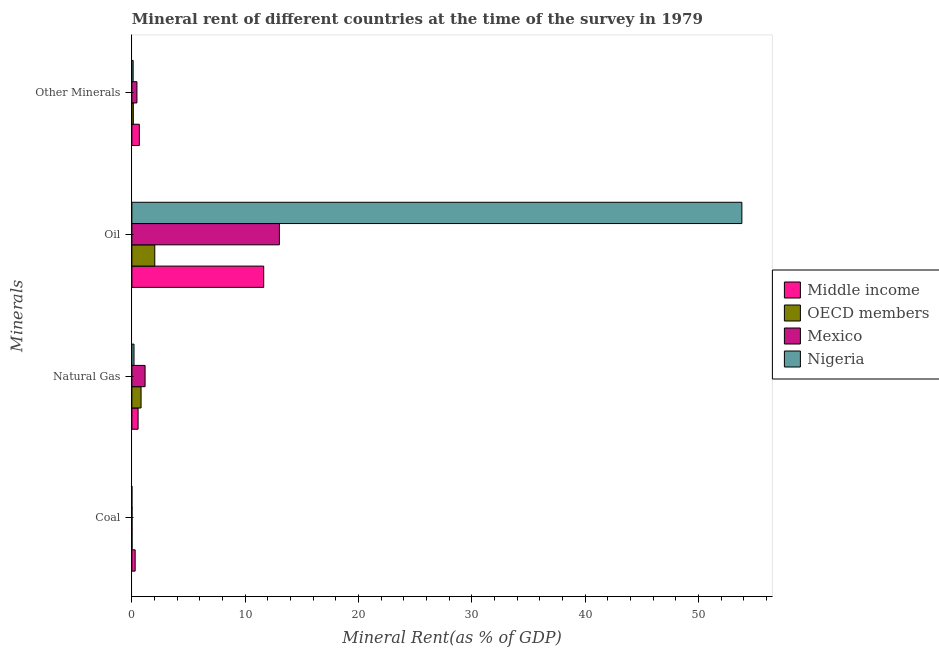How many bars are there on the 3rd tick from the bottom?
Offer a terse response. 4. What is the label of the 3rd group of bars from the top?
Provide a short and direct response. Natural Gas. What is the natural gas rent in OECD members?
Your answer should be very brief. 0.81. Across all countries, what is the maximum natural gas rent?
Ensure brevity in your answer.  1.16. Across all countries, what is the minimum oil rent?
Your answer should be compact. 2.02. What is the total coal rent in the graph?
Provide a short and direct response. 0.32. What is the difference between the oil rent in Nigeria and that in OECD members?
Offer a very short reply. 51.81. What is the difference between the oil rent in Nigeria and the coal rent in Middle income?
Make the answer very short. 53.54. What is the average  rent of other minerals per country?
Your answer should be compact. 0.34. What is the difference between the oil rent and coal rent in Mexico?
Your answer should be very brief. 13. What is the ratio of the natural gas rent in Mexico to that in Middle income?
Your answer should be compact. 2.13. What is the difference between the highest and the second highest natural gas rent?
Give a very brief answer. 0.35. What is the difference between the highest and the lowest  rent of other minerals?
Provide a succinct answer. 0.55. In how many countries, is the natural gas rent greater than the average natural gas rent taken over all countries?
Make the answer very short. 2. What does the 3rd bar from the top in Other Minerals represents?
Offer a very short reply. OECD members. Is it the case that in every country, the sum of the coal rent and natural gas rent is greater than the oil rent?
Your response must be concise. No. How many bars are there?
Your response must be concise. 16. Are all the bars in the graph horizontal?
Give a very brief answer. Yes. Are the values on the major ticks of X-axis written in scientific E-notation?
Your answer should be very brief. No. Does the graph contain any zero values?
Give a very brief answer. No. How many legend labels are there?
Provide a succinct answer. 4. How are the legend labels stacked?
Your answer should be compact. Vertical. What is the title of the graph?
Give a very brief answer. Mineral rent of different countries at the time of the survey in 1979. What is the label or title of the X-axis?
Ensure brevity in your answer.  Mineral Rent(as % of GDP). What is the label or title of the Y-axis?
Give a very brief answer. Minerals. What is the Mineral Rent(as % of GDP) of Middle income in Coal?
Keep it short and to the point. 0.29. What is the Mineral Rent(as % of GDP) of OECD members in Coal?
Keep it short and to the point. 0.02. What is the Mineral Rent(as % of GDP) of Mexico in Coal?
Provide a short and direct response. 0.01. What is the Mineral Rent(as % of GDP) of Nigeria in Coal?
Make the answer very short. 0. What is the Mineral Rent(as % of GDP) of Middle income in Natural Gas?
Make the answer very short. 0.55. What is the Mineral Rent(as % of GDP) in OECD members in Natural Gas?
Keep it short and to the point. 0.81. What is the Mineral Rent(as % of GDP) in Mexico in Natural Gas?
Keep it short and to the point. 1.16. What is the Mineral Rent(as % of GDP) in Nigeria in Natural Gas?
Give a very brief answer. 0.19. What is the Mineral Rent(as % of GDP) in Middle income in Oil?
Keep it short and to the point. 11.63. What is the Mineral Rent(as % of GDP) in OECD members in Oil?
Offer a very short reply. 2.02. What is the Mineral Rent(as % of GDP) in Mexico in Oil?
Your response must be concise. 13.02. What is the Mineral Rent(as % of GDP) in Nigeria in Oil?
Offer a terse response. 53.83. What is the Mineral Rent(as % of GDP) of Middle income in Other Minerals?
Give a very brief answer. 0.66. What is the Mineral Rent(as % of GDP) in OECD members in Other Minerals?
Give a very brief answer. 0.13. What is the Mineral Rent(as % of GDP) of Mexico in Other Minerals?
Provide a succinct answer. 0.45. What is the Mineral Rent(as % of GDP) of Nigeria in Other Minerals?
Offer a very short reply. 0.11. Across all Minerals, what is the maximum Mineral Rent(as % of GDP) of Middle income?
Provide a short and direct response. 11.63. Across all Minerals, what is the maximum Mineral Rent(as % of GDP) in OECD members?
Your answer should be very brief. 2.02. Across all Minerals, what is the maximum Mineral Rent(as % of GDP) of Mexico?
Offer a very short reply. 13.02. Across all Minerals, what is the maximum Mineral Rent(as % of GDP) in Nigeria?
Your response must be concise. 53.83. Across all Minerals, what is the minimum Mineral Rent(as % of GDP) of Middle income?
Ensure brevity in your answer.  0.29. Across all Minerals, what is the minimum Mineral Rent(as % of GDP) in OECD members?
Provide a succinct answer. 0.02. Across all Minerals, what is the minimum Mineral Rent(as % of GDP) in Mexico?
Provide a short and direct response. 0.01. Across all Minerals, what is the minimum Mineral Rent(as % of GDP) in Nigeria?
Your answer should be very brief. 0. What is the total Mineral Rent(as % of GDP) of Middle income in the graph?
Offer a terse response. 13.13. What is the total Mineral Rent(as % of GDP) of OECD members in the graph?
Your answer should be compact. 2.97. What is the total Mineral Rent(as % of GDP) in Mexico in the graph?
Provide a short and direct response. 14.64. What is the total Mineral Rent(as % of GDP) in Nigeria in the graph?
Provide a succinct answer. 54.13. What is the difference between the Mineral Rent(as % of GDP) in Middle income in Coal and that in Natural Gas?
Make the answer very short. -0.26. What is the difference between the Mineral Rent(as % of GDP) of OECD members in Coal and that in Natural Gas?
Offer a terse response. -0.8. What is the difference between the Mineral Rent(as % of GDP) in Mexico in Coal and that in Natural Gas?
Keep it short and to the point. -1.15. What is the difference between the Mineral Rent(as % of GDP) in Nigeria in Coal and that in Natural Gas?
Ensure brevity in your answer.  -0.19. What is the difference between the Mineral Rent(as % of GDP) of Middle income in Coal and that in Oil?
Ensure brevity in your answer.  -11.34. What is the difference between the Mineral Rent(as % of GDP) of OECD members in Coal and that in Oil?
Provide a short and direct response. -2.01. What is the difference between the Mineral Rent(as % of GDP) in Mexico in Coal and that in Oil?
Ensure brevity in your answer.  -13. What is the difference between the Mineral Rent(as % of GDP) of Nigeria in Coal and that in Oil?
Keep it short and to the point. -53.83. What is the difference between the Mineral Rent(as % of GDP) of Middle income in Coal and that in Other Minerals?
Offer a terse response. -0.37. What is the difference between the Mineral Rent(as % of GDP) in OECD members in Coal and that in Other Minerals?
Offer a terse response. -0.11. What is the difference between the Mineral Rent(as % of GDP) of Mexico in Coal and that in Other Minerals?
Offer a terse response. -0.43. What is the difference between the Mineral Rent(as % of GDP) of Nigeria in Coal and that in Other Minerals?
Your answer should be compact. -0.11. What is the difference between the Mineral Rent(as % of GDP) in Middle income in Natural Gas and that in Oil?
Give a very brief answer. -11.08. What is the difference between the Mineral Rent(as % of GDP) of OECD members in Natural Gas and that in Oil?
Ensure brevity in your answer.  -1.21. What is the difference between the Mineral Rent(as % of GDP) in Mexico in Natural Gas and that in Oil?
Keep it short and to the point. -11.85. What is the difference between the Mineral Rent(as % of GDP) in Nigeria in Natural Gas and that in Oil?
Offer a very short reply. -53.64. What is the difference between the Mineral Rent(as % of GDP) of Middle income in Natural Gas and that in Other Minerals?
Give a very brief answer. -0.11. What is the difference between the Mineral Rent(as % of GDP) in OECD members in Natural Gas and that in Other Minerals?
Ensure brevity in your answer.  0.68. What is the difference between the Mineral Rent(as % of GDP) in Mexico in Natural Gas and that in Other Minerals?
Make the answer very short. 0.72. What is the difference between the Mineral Rent(as % of GDP) of Nigeria in Natural Gas and that in Other Minerals?
Give a very brief answer. 0.08. What is the difference between the Mineral Rent(as % of GDP) of Middle income in Oil and that in Other Minerals?
Offer a very short reply. 10.97. What is the difference between the Mineral Rent(as % of GDP) of OECD members in Oil and that in Other Minerals?
Offer a terse response. 1.89. What is the difference between the Mineral Rent(as % of GDP) in Mexico in Oil and that in Other Minerals?
Your answer should be very brief. 12.57. What is the difference between the Mineral Rent(as % of GDP) in Nigeria in Oil and that in Other Minerals?
Offer a terse response. 53.72. What is the difference between the Mineral Rent(as % of GDP) of Middle income in Coal and the Mineral Rent(as % of GDP) of OECD members in Natural Gas?
Your answer should be very brief. -0.52. What is the difference between the Mineral Rent(as % of GDP) in Middle income in Coal and the Mineral Rent(as % of GDP) in Mexico in Natural Gas?
Offer a very short reply. -0.88. What is the difference between the Mineral Rent(as % of GDP) in Middle income in Coal and the Mineral Rent(as % of GDP) in Nigeria in Natural Gas?
Make the answer very short. 0.1. What is the difference between the Mineral Rent(as % of GDP) in OECD members in Coal and the Mineral Rent(as % of GDP) in Mexico in Natural Gas?
Give a very brief answer. -1.15. What is the difference between the Mineral Rent(as % of GDP) of OECD members in Coal and the Mineral Rent(as % of GDP) of Nigeria in Natural Gas?
Make the answer very short. -0.17. What is the difference between the Mineral Rent(as % of GDP) in Mexico in Coal and the Mineral Rent(as % of GDP) in Nigeria in Natural Gas?
Ensure brevity in your answer.  -0.18. What is the difference between the Mineral Rent(as % of GDP) of Middle income in Coal and the Mineral Rent(as % of GDP) of OECD members in Oil?
Your answer should be compact. -1.73. What is the difference between the Mineral Rent(as % of GDP) in Middle income in Coal and the Mineral Rent(as % of GDP) in Mexico in Oil?
Provide a short and direct response. -12.73. What is the difference between the Mineral Rent(as % of GDP) of Middle income in Coal and the Mineral Rent(as % of GDP) of Nigeria in Oil?
Ensure brevity in your answer.  -53.54. What is the difference between the Mineral Rent(as % of GDP) in OECD members in Coal and the Mineral Rent(as % of GDP) in Mexico in Oil?
Your answer should be very brief. -13. What is the difference between the Mineral Rent(as % of GDP) of OECD members in Coal and the Mineral Rent(as % of GDP) of Nigeria in Oil?
Offer a very short reply. -53.81. What is the difference between the Mineral Rent(as % of GDP) in Mexico in Coal and the Mineral Rent(as % of GDP) in Nigeria in Oil?
Keep it short and to the point. -53.81. What is the difference between the Mineral Rent(as % of GDP) of Middle income in Coal and the Mineral Rent(as % of GDP) of OECD members in Other Minerals?
Make the answer very short. 0.16. What is the difference between the Mineral Rent(as % of GDP) in Middle income in Coal and the Mineral Rent(as % of GDP) in Mexico in Other Minerals?
Make the answer very short. -0.16. What is the difference between the Mineral Rent(as % of GDP) in Middle income in Coal and the Mineral Rent(as % of GDP) in Nigeria in Other Minerals?
Your answer should be compact. 0.18. What is the difference between the Mineral Rent(as % of GDP) in OECD members in Coal and the Mineral Rent(as % of GDP) in Mexico in Other Minerals?
Your response must be concise. -0.43. What is the difference between the Mineral Rent(as % of GDP) in OECD members in Coal and the Mineral Rent(as % of GDP) in Nigeria in Other Minerals?
Your answer should be very brief. -0.1. What is the difference between the Mineral Rent(as % of GDP) in Mexico in Coal and the Mineral Rent(as % of GDP) in Nigeria in Other Minerals?
Your response must be concise. -0.1. What is the difference between the Mineral Rent(as % of GDP) of Middle income in Natural Gas and the Mineral Rent(as % of GDP) of OECD members in Oil?
Give a very brief answer. -1.47. What is the difference between the Mineral Rent(as % of GDP) in Middle income in Natural Gas and the Mineral Rent(as % of GDP) in Mexico in Oil?
Give a very brief answer. -12.47. What is the difference between the Mineral Rent(as % of GDP) of Middle income in Natural Gas and the Mineral Rent(as % of GDP) of Nigeria in Oil?
Provide a succinct answer. -53.28. What is the difference between the Mineral Rent(as % of GDP) in OECD members in Natural Gas and the Mineral Rent(as % of GDP) in Mexico in Oil?
Offer a terse response. -12.21. What is the difference between the Mineral Rent(as % of GDP) of OECD members in Natural Gas and the Mineral Rent(as % of GDP) of Nigeria in Oil?
Provide a succinct answer. -53.02. What is the difference between the Mineral Rent(as % of GDP) in Mexico in Natural Gas and the Mineral Rent(as % of GDP) in Nigeria in Oil?
Make the answer very short. -52.66. What is the difference between the Mineral Rent(as % of GDP) in Middle income in Natural Gas and the Mineral Rent(as % of GDP) in OECD members in Other Minerals?
Your response must be concise. 0.42. What is the difference between the Mineral Rent(as % of GDP) in Middle income in Natural Gas and the Mineral Rent(as % of GDP) in Mexico in Other Minerals?
Provide a short and direct response. 0.1. What is the difference between the Mineral Rent(as % of GDP) in Middle income in Natural Gas and the Mineral Rent(as % of GDP) in Nigeria in Other Minerals?
Your response must be concise. 0.44. What is the difference between the Mineral Rent(as % of GDP) of OECD members in Natural Gas and the Mineral Rent(as % of GDP) of Mexico in Other Minerals?
Offer a very short reply. 0.36. What is the difference between the Mineral Rent(as % of GDP) of OECD members in Natural Gas and the Mineral Rent(as % of GDP) of Nigeria in Other Minerals?
Your answer should be very brief. 0.7. What is the difference between the Mineral Rent(as % of GDP) of Mexico in Natural Gas and the Mineral Rent(as % of GDP) of Nigeria in Other Minerals?
Offer a terse response. 1.05. What is the difference between the Mineral Rent(as % of GDP) of Middle income in Oil and the Mineral Rent(as % of GDP) of OECD members in Other Minerals?
Your answer should be compact. 11.51. What is the difference between the Mineral Rent(as % of GDP) of Middle income in Oil and the Mineral Rent(as % of GDP) of Mexico in Other Minerals?
Ensure brevity in your answer.  11.19. What is the difference between the Mineral Rent(as % of GDP) in Middle income in Oil and the Mineral Rent(as % of GDP) in Nigeria in Other Minerals?
Your answer should be very brief. 11.52. What is the difference between the Mineral Rent(as % of GDP) in OECD members in Oil and the Mineral Rent(as % of GDP) in Mexico in Other Minerals?
Give a very brief answer. 1.57. What is the difference between the Mineral Rent(as % of GDP) in OECD members in Oil and the Mineral Rent(as % of GDP) in Nigeria in Other Minerals?
Offer a very short reply. 1.91. What is the difference between the Mineral Rent(as % of GDP) in Mexico in Oil and the Mineral Rent(as % of GDP) in Nigeria in Other Minerals?
Offer a very short reply. 12.91. What is the average Mineral Rent(as % of GDP) of Middle income per Minerals?
Offer a very short reply. 3.28. What is the average Mineral Rent(as % of GDP) in OECD members per Minerals?
Offer a very short reply. 0.74. What is the average Mineral Rent(as % of GDP) of Mexico per Minerals?
Your response must be concise. 3.66. What is the average Mineral Rent(as % of GDP) in Nigeria per Minerals?
Make the answer very short. 13.53. What is the difference between the Mineral Rent(as % of GDP) of Middle income and Mineral Rent(as % of GDP) of OECD members in Coal?
Keep it short and to the point. 0.27. What is the difference between the Mineral Rent(as % of GDP) in Middle income and Mineral Rent(as % of GDP) in Mexico in Coal?
Provide a succinct answer. 0.28. What is the difference between the Mineral Rent(as % of GDP) in Middle income and Mineral Rent(as % of GDP) in Nigeria in Coal?
Provide a succinct answer. 0.29. What is the difference between the Mineral Rent(as % of GDP) in OECD members and Mineral Rent(as % of GDP) in Mexico in Coal?
Provide a succinct answer. 0. What is the difference between the Mineral Rent(as % of GDP) of OECD members and Mineral Rent(as % of GDP) of Nigeria in Coal?
Provide a succinct answer. 0.01. What is the difference between the Mineral Rent(as % of GDP) of Mexico and Mineral Rent(as % of GDP) of Nigeria in Coal?
Your response must be concise. 0.01. What is the difference between the Mineral Rent(as % of GDP) in Middle income and Mineral Rent(as % of GDP) in OECD members in Natural Gas?
Offer a very short reply. -0.26. What is the difference between the Mineral Rent(as % of GDP) of Middle income and Mineral Rent(as % of GDP) of Mexico in Natural Gas?
Make the answer very short. -0.62. What is the difference between the Mineral Rent(as % of GDP) of Middle income and Mineral Rent(as % of GDP) of Nigeria in Natural Gas?
Provide a short and direct response. 0.36. What is the difference between the Mineral Rent(as % of GDP) in OECD members and Mineral Rent(as % of GDP) in Mexico in Natural Gas?
Offer a very short reply. -0.35. What is the difference between the Mineral Rent(as % of GDP) in OECD members and Mineral Rent(as % of GDP) in Nigeria in Natural Gas?
Keep it short and to the point. 0.62. What is the difference between the Mineral Rent(as % of GDP) of Mexico and Mineral Rent(as % of GDP) of Nigeria in Natural Gas?
Make the answer very short. 0.98. What is the difference between the Mineral Rent(as % of GDP) in Middle income and Mineral Rent(as % of GDP) in OECD members in Oil?
Offer a terse response. 9.61. What is the difference between the Mineral Rent(as % of GDP) in Middle income and Mineral Rent(as % of GDP) in Mexico in Oil?
Offer a terse response. -1.38. What is the difference between the Mineral Rent(as % of GDP) in Middle income and Mineral Rent(as % of GDP) in Nigeria in Oil?
Your response must be concise. -42.19. What is the difference between the Mineral Rent(as % of GDP) of OECD members and Mineral Rent(as % of GDP) of Mexico in Oil?
Give a very brief answer. -11. What is the difference between the Mineral Rent(as % of GDP) of OECD members and Mineral Rent(as % of GDP) of Nigeria in Oil?
Provide a succinct answer. -51.81. What is the difference between the Mineral Rent(as % of GDP) in Mexico and Mineral Rent(as % of GDP) in Nigeria in Oil?
Offer a terse response. -40.81. What is the difference between the Mineral Rent(as % of GDP) in Middle income and Mineral Rent(as % of GDP) in OECD members in Other Minerals?
Offer a terse response. 0.53. What is the difference between the Mineral Rent(as % of GDP) of Middle income and Mineral Rent(as % of GDP) of Mexico in Other Minerals?
Give a very brief answer. 0.21. What is the difference between the Mineral Rent(as % of GDP) in Middle income and Mineral Rent(as % of GDP) in Nigeria in Other Minerals?
Provide a short and direct response. 0.55. What is the difference between the Mineral Rent(as % of GDP) in OECD members and Mineral Rent(as % of GDP) in Mexico in Other Minerals?
Keep it short and to the point. -0.32. What is the difference between the Mineral Rent(as % of GDP) in OECD members and Mineral Rent(as % of GDP) in Nigeria in Other Minerals?
Your response must be concise. 0.02. What is the difference between the Mineral Rent(as % of GDP) of Mexico and Mineral Rent(as % of GDP) of Nigeria in Other Minerals?
Your answer should be compact. 0.34. What is the ratio of the Mineral Rent(as % of GDP) of Middle income in Coal to that in Natural Gas?
Provide a short and direct response. 0.53. What is the ratio of the Mineral Rent(as % of GDP) of OECD members in Coal to that in Natural Gas?
Your response must be concise. 0.02. What is the ratio of the Mineral Rent(as % of GDP) in Mexico in Coal to that in Natural Gas?
Offer a very short reply. 0.01. What is the ratio of the Mineral Rent(as % of GDP) in Nigeria in Coal to that in Natural Gas?
Your answer should be compact. 0.01. What is the ratio of the Mineral Rent(as % of GDP) of Middle income in Coal to that in Oil?
Offer a very short reply. 0.02. What is the ratio of the Mineral Rent(as % of GDP) in OECD members in Coal to that in Oil?
Keep it short and to the point. 0.01. What is the ratio of the Mineral Rent(as % of GDP) in Mexico in Coal to that in Oil?
Your answer should be compact. 0. What is the ratio of the Mineral Rent(as % of GDP) of Nigeria in Coal to that in Oil?
Make the answer very short. 0. What is the ratio of the Mineral Rent(as % of GDP) of Middle income in Coal to that in Other Minerals?
Give a very brief answer. 0.44. What is the ratio of the Mineral Rent(as % of GDP) in OECD members in Coal to that in Other Minerals?
Provide a short and direct response. 0.12. What is the ratio of the Mineral Rent(as % of GDP) of Mexico in Coal to that in Other Minerals?
Make the answer very short. 0.03. What is the ratio of the Mineral Rent(as % of GDP) of Nigeria in Coal to that in Other Minerals?
Offer a very short reply. 0.01. What is the ratio of the Mineral Rent(as % of GDP) in Middle income in Natural Gas to that in Oil?
Make the answer very short. 0.05. What is the ratio of the Mineral Rent(as % of GDP) of OECD members in Natural Gas to that in Oil?
Provide a succinct answer. 0.4. What is the ratio of the Mineral Rent(as % of GDP) of Mexico in Natural Gas to that in Oil?
Ensure brevity in your answer.  0.09. What is the ratio of the Mineral Rent(as % of GDP) in Nigeria in Natural Gas to that in Oil?
Your response must be concise. 0. What is the ratio of the Mineral Rent(as % of GDP) of Middle income in Natural Gas to that in Other Minerals?
Offer a very short reply. 0.83. What is the ratio of the Mineral Rent(as % of GDP) of OECD members in Natural Gas to that in Other Minerals?
Make the answer very short. 6.41. What is the ratio of the Mineral Rent(as % of GDP) in Mexico in Natural Gas to that in Other Minerals?
Your response must be concise. 2.61. What is the ratio of the Mineral Rent(as % of GDP) of Nigeria in Natural Gas to that in Other Minerals?
Provide a short and direct response. 1.7. What is the ratio of the Mineral Rent(as % of GDP) of Middle income in Oil to that in Other Minerals?
Offer a terse response. 17.63. What is the ratio of the Mineral Rent(as % of GDP) in OECD members in Oil to that in Other Minerals?
Make the answer very short. 15.97. What is the ratio of the Mineral Rent(as % of GDP) in Mexico in Oil to that in Other Minerals?
Your response must be concise. 29.16. What is the ratio of the Mineral Rent(as % of GDP) of Nigeria in Oil to that in Other Minerals?
Provide a short and direct response. 484.18. What is the difference between the highest and the second highest Mineral Rent(as % of GDP) in Middle income?
Ensure brevity in your answer.  10.97. What is the difference between the highest and the second highest Mineral Rent(as % of GDP) in OECD members?
Give a very brief answer. 1.21. What is the difference between the highest and the second highest Mineral Rent(as % of GDP) in Mexico?
Ensure brevity in your answer.  11.85. What is the difference between the highest and the second highest Mineral Rent(as % of GDP) of Nigeria?
Offer a very short reply. 53.64. What is the difference between the highest and the lowest Mineral Rent(as % of GDP) in Middle income?
Ensure brevity in your answer.  11.34. What is the difference between the highest and the lowest Mineral Rent(as % of GDP) in OECD members?
Your answer should be very brief. 2.01. What is the difference between the highest and the lowest Mineral Rent(as % of GDP) in Mexico?
Your answer should be very brief. 13. What is the difference between the highest and the lowest Mineral Rent(as % of GDP) in Nigeria?
Offer a terse response. 53.83. 